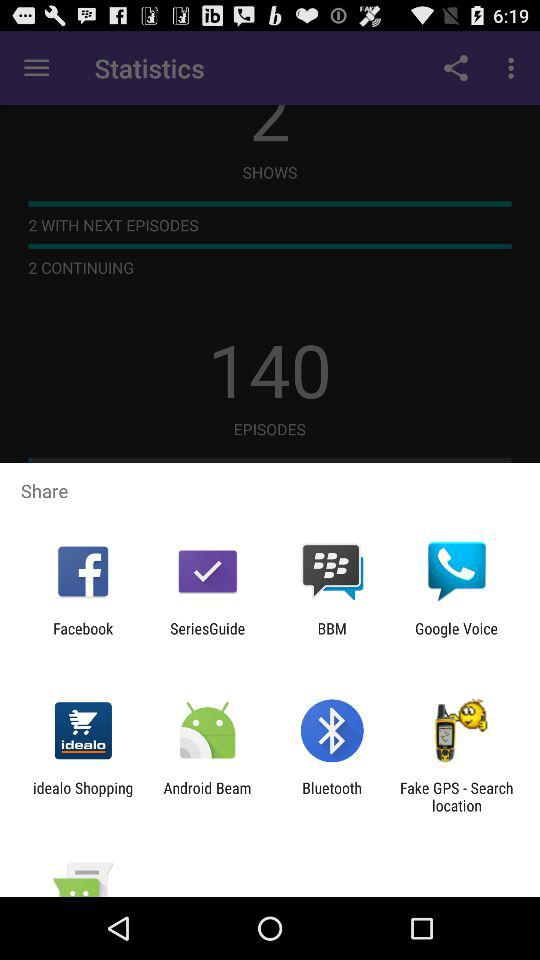What applications can be used to share? The applications that can be used to share are "Facebook", "SeriesGuide", "BBM", "Google Voice", "idealo Shopping", "Android Beam", "Bluetooth" and "Fake GPS - Search location". 